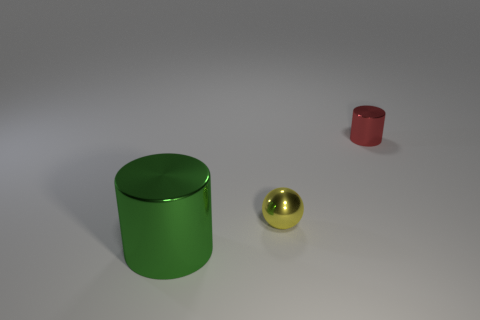The thing that is the same size as the red metallic cylinder is what color?
Ensure brevity in your answer.  Yellow. What size is the green cylinder that is the same material as the tiny sphere?
Offer a terse response. Large. How many other objects are the same size as the red metal object?
Offer a terse response. 1. What is the cylinder that is behind the tiny yellow metallic object made of?
Your response must be concise. Metal. There is a yellow shiny object that is to the left of the cylinder that is on the right side of the shiny cylinder in front of the ball; what is its shape?
Provide a short and direct response. Sphere. Is the red cylinder the same size as the yellow shiny thing?
Ensure brevity in your answer.  Yes. How many objects are either big purple balls or metallic objects behind the yellow metal sphere?
Provide a short and direct response. 1. How many things are shiny cylinders in front of the red shiny object or red metallic objects behind the big green thing?
Your answer should be very brief. 2. There is a big thing; are there any metal objects behind it?
Ensure brevity in your answer.  Yes. The cylinder that is behind the metallic cylinder that is in front of the cylinder that is behind the green thing is what color?
Your answer should be compact. Red. 